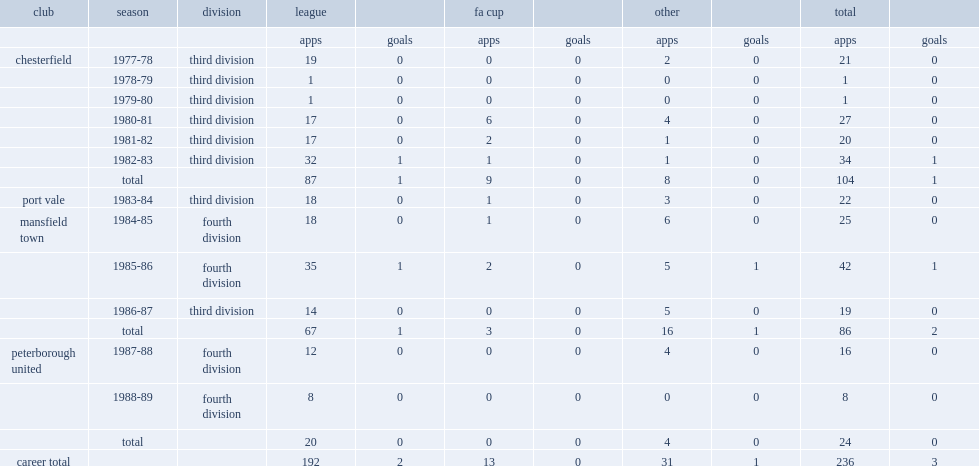Which division did pollard begin his career at chesterfield in 1977-78? Third division. 